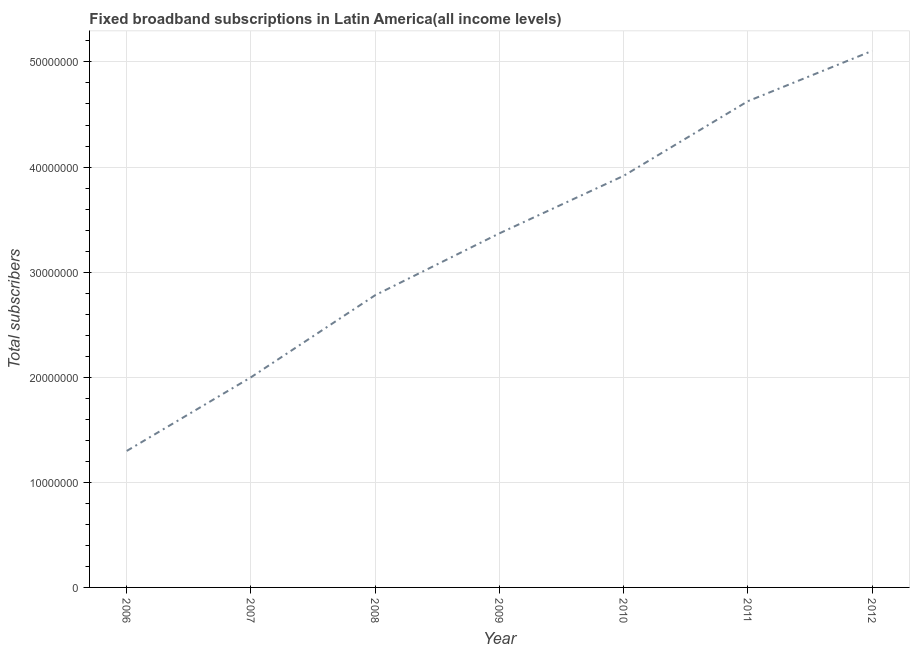What is the total number of fixed broadband subscriptions in 2011?
Provide a short and direct response. 4.63e+07. Across all years, what is the maximum total number of fixed broadband subscriptions?
Keep it short and to the point. 5.11e+07. Across all years, what is the minimum total number of fixed broadband subscriptions?
Provide a short and direct response. 1.30e+07. What is the sum of the total number of fixed broadband subscriptions?
Provide a succinct answer. 2.31e+08. What is the difference between the total number of fixed broadband subscriptions in 2009 and 2012?
Make the answer very short. -1.74e+07. What is the average total number of fixed broadband subscriptions per year?
Provide a succinct answer. 3.30e+07. What is the median total number of fixed broadband subscriptions?
Offer a terse response. 3.37e+07. In how many years, is the total number of fixed broadband subscriptions greater than 40000000 ?
Give a very brief answer. 2. What is the ratio of the total number of fixed broadband subscriptions in 2010 to that in 2011?
Your answer should be very brief. 0.85. Is the total number of fixed broadband subscriptions in 2006 less than that in 2012?
Your answer should be very brief. Yes. Is the difference between the total number of fixed broadband subscriptions in 2007 and 2012 greater than the difference between any two years?
Make the answer very short. No. What is the difference between the highest and the second highest total number of fixed broadband subscriptions?
Your answer should be compact. 4.79e+06. What is the difference between the highest and the lowest total number of fixed broadband subscriptions?
Provide a short and direct response. 3.81e+07. In how many years, is the total number of fixed broadband subscriptions greater than the average total number of fixed broadband subscriptions taken over all years?
Your response must be concise. 4. How many years are there in the graph?
Provide a succinct answer. 7. What is the difference between two consecutive major ticks on the Y-axis?
Provide a short and direct response. 1.00e+07. What is the title of the graph?
Make the answer very short. Fixed broadband subscriptions in Latin America(all income levels). What is the label or title of the X-axis?
Your response must be concise. Year. What is the label or title of the Y-axis?
Ensure brevity in your answer.  Total subscribers. What is the Total subscribers of 2006?
Ensure brevity in your answer.  1.30e+07. What is the Total subscribers in 2007?
Ensure brevity in your answer.  2.00e+07. What is the Total subscribers of 2008?
Keep it short and to the point. 2.78e+07. What is the Total subscribers of 2009?
Provide a succinct answer. 3.37e+07. What is the Total subscribers of 2010?
Make the answer very short. 3.92e+07. What is the Total subscribers of 2011?
Make the answer very short. 4.63e+07. What is the Total subscribers in 2012?
Ensure brevity in your answer.  5.11e+07. What is the difference between the Total subscribers in 2006 and 2007?
Your response must be concise. -7.01e+06. What is the difference between the Total subscribers in 2006 and 2008?
Your answer should be compact. -1.48e+07. What is the difference between the Total subscribers in 2006 and 2009?
Keep it short and to the point. -2.07e+07. What is the difference between the Total subscribers in 2006 and 2010?
Give a very brief answer. -2.62e+07. What is the difference between the Total subscribers in 2006 and 2011?
Give a very brief answer. -3.33e+07. What is the difference between the Total subscribers in 2006 and 2012?
Ensure brevity in your answer.  -3.81e+07. What is the difference between the Total subscribers in 2007 and 2008?
Provide a short and direct response. -7.81e+06. What is the difference between the Total subscribers in 2007 and 2009?
Provide a succinct answer. -1.37e+07. What is the difference between the Total subscribers in 2007 and 2010?
Your answer should be compact. -1.92e+07. What is the difference between the Total subscribers in 2007 and 2011?
Give a very brief answer. -2.63e+07. What is the difference between the Total subscribers in 2007 and 2012?
Provide a short and direct response. -3.11e+07. What is the difference between the Total subscribers in 2008 and 2009?
Make the answer very short. -5.88e+06. What is the difference between the Total subscribers in 2008 and 2010?
Your response must be concise. -1.14e+07. What is the difference between the Total subscribers in 2008 and 2011?
Give a very brief answer. -1.85e+07. What is the difference between the Total subscribers in 2008 and 2012?
Make the answer very short. -2.32e+07. What is the difference between the Total subscribers in 2009 and 2010?
Your answer should be very brief. -5.48e+06. What is the difference between the Total subscribers in 2009 and 2011?
Ensure brevity in your answer.  -1.26e+07. What is the difference between the Total subscribers in 2009 and 2012?
Provide a succinct answer. -1.74e+07. What is the difference between the Total subscribers in 2010 and 2011?
Your answer should be compact. -7.10e+06. What is the difference between the Total subscribers in 2010 and 2012?
Give a very brief answer. -1.19e+07. What is the difference between the Total subscribers in 2011 and 2012?
Offer a terse response. -4.79e+06. What is the ratio of the Total subscribers in 2006 to that in 2007?
Provide a short and direct response. 0.65. What is the ratio of the Total subscribers in 2006 to that in 2008?
Make the answer very short. 0.47. What is the ratio of the Total subscribers in 2006 to that in 2009?
Offer a terse response. 0.39. What is the ratio of the Total subscribers in 2006 to that in 2010?
Make the answer very short. 0.33. What is the ratio of the Total subscribers in 2006 to that in 2011?
Offer a terse response. 0.28. What is the ratio of the Total subscribers in 2006 to that in 2012?
Keep it short and to the point. 0.25. What is the ratio of the Total subscribers in 2007 to that in 2008?
Your answer should be compact. 0.72. What is the ratio of the Total subscribers in 2007 to that in 2009?
Your answer should be compact. 0.59. What is the ratio of the Total subscribers in 2007 to that in 2010?
Give a very brief answer. 0.51. What is the ratio of the Total subscribers in 2007 to that in 2011?
Provide a short and direct response. 0.43. What is the ratio of the Total subscribers in 2007 to that in 2012?
Make the answer very short. 0.39. What is the ratio of the Total subscribers in 2008 to that in 2009?
Your answer should be very brief. 0.82. What is the ratio of the Total subscribers in 2008 to that in 2010?
Offer a terse response. 0.71. What is the ratio of the Total subscribers in 2008 to that in 2011?
Your answer should be very brief. 0.6. What is the ratio of the Total subscribers in 2008 to that in 2012?
Your answer should be compact. 0.55. What is the ratio of the Total subscribers in 2009 to that in 2010?
Provide a succinct answer. 0.86. What is the ratio of the Total subscribers in 2009 to that in 2011?
Keep it short and to the point. 0.73. What is the ratio of the Total subscribers in 2009 to that in 2012?
Provide a short and direct response. 0.66. What is the ratio of the Total subscribers in 2010 to that in 2011?
Provide a short and direct response. 0.85. What is the ratio of the Total subscribers in 2010 to that in 2012?
Offer a very short reply. 0.77. What is the ratio of the Total subscribers in 2011 to that in 2012?
Keep it short and to the point. 0.91. 